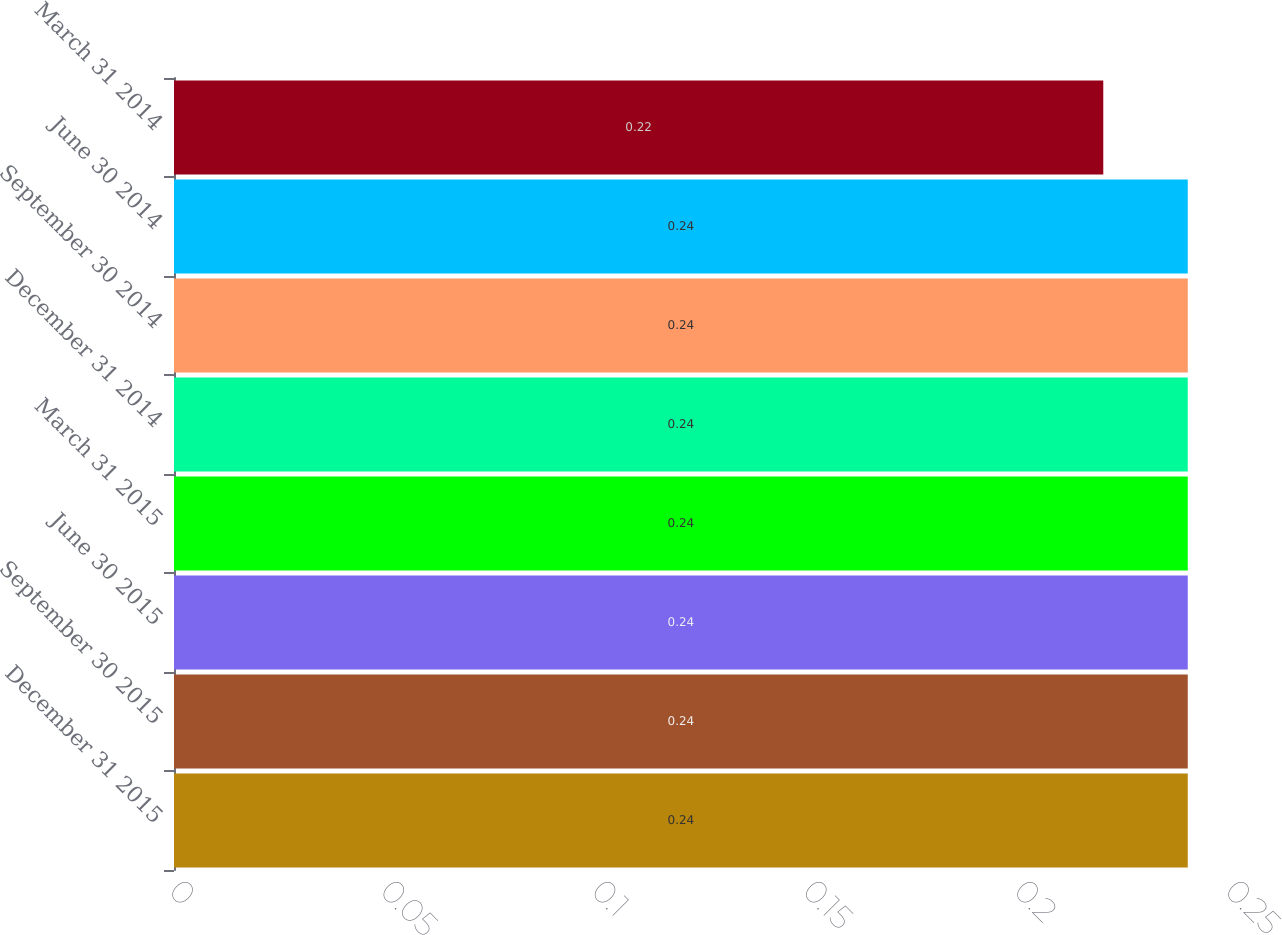Convert chart. <chart><loc_0><loc_0><loc_500><loc_500><bar_chart><fcel>December 31 2015<fcel>September 30 2015<fcel>June 30 2015<fcel>March 31 2015<fcel>December 31 2014<fcel>September 30 2014<fcel>June 30 2014<fcel>March 31 2014<nl><fcel>0.24<fcel>0.24<fcel>0.24<fcel>0.24<fcel>0.24<fcel>0.24<fcel>0.24<fcel>0.22<nl></chart> 